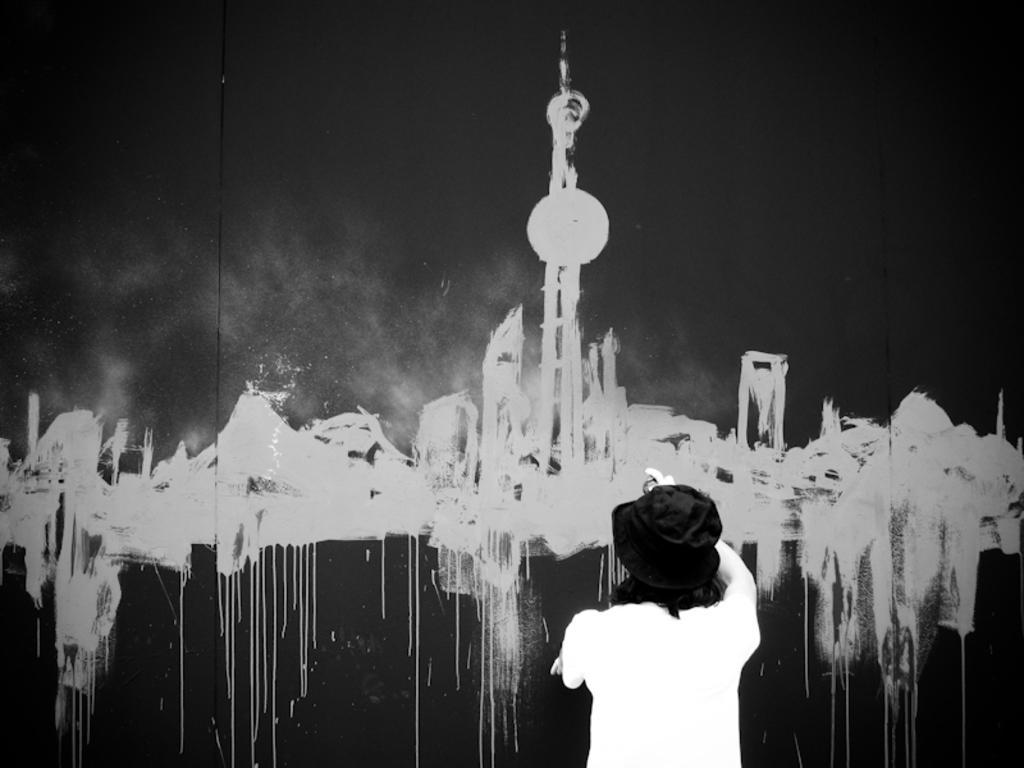How would you summarize this image in a sentence or two? On the right side, there is a person in white color T-shirt, painting on the wall. In this painting, there is a tower and there are some objects. And the background of this painting is dark in color. 